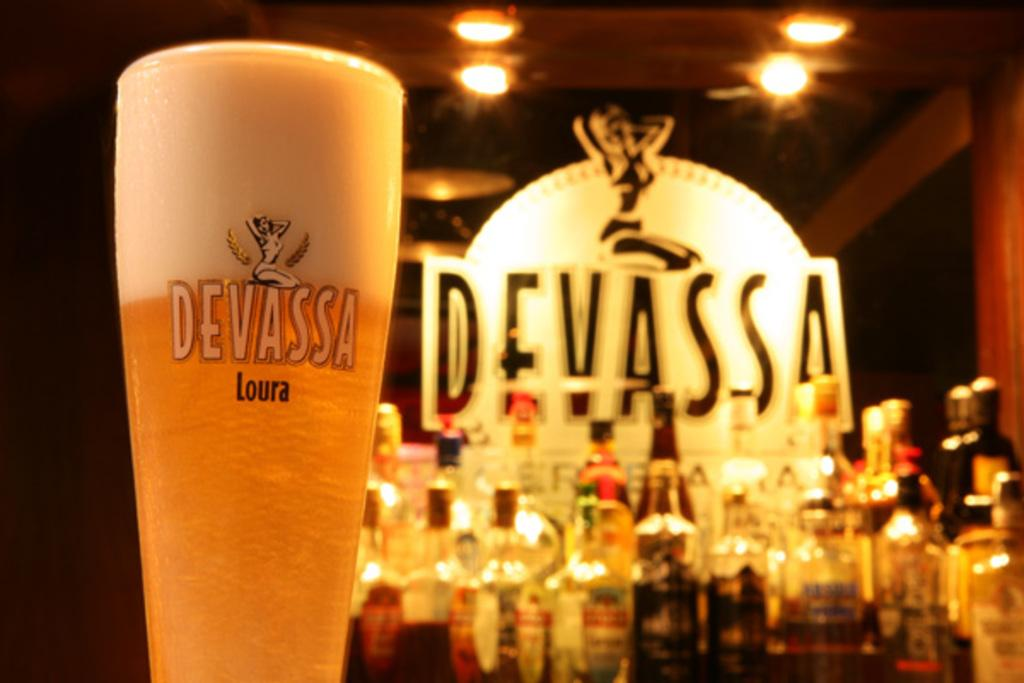<image>
Present a compact description of the photo's key features. A glass of Devassa beer with foam at the top. 